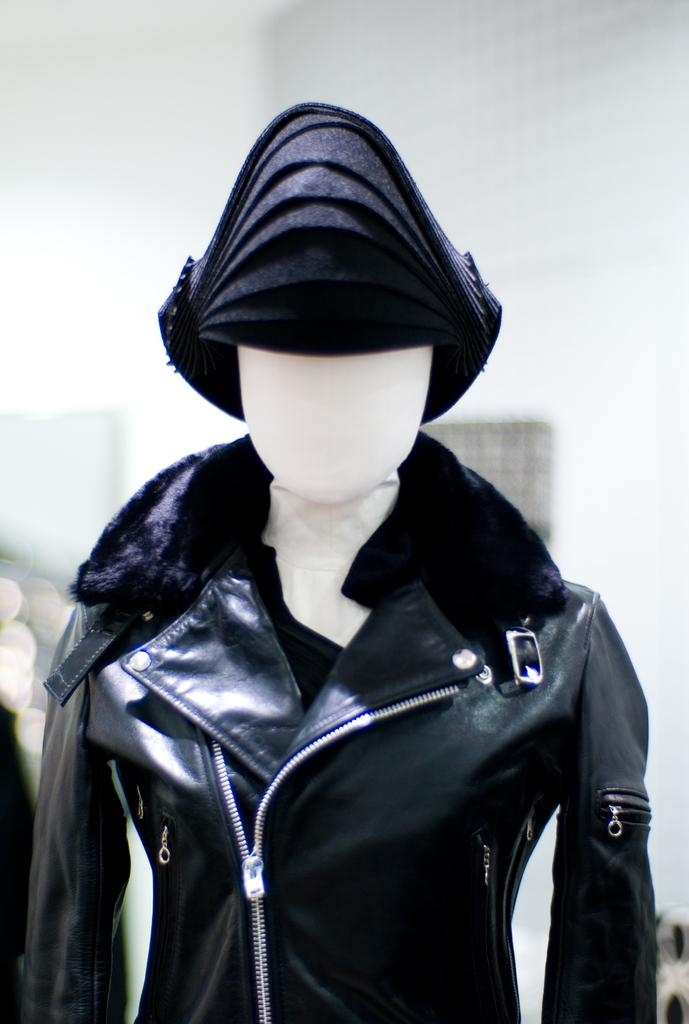What is the main subject in the picture? There is a mannequin in the picture. What is the mannequin wearing in the picture? There is a black color jacket in the picture. Can you tell me how the woman in the picture is controlling the mannequin? There is no woman present in the image, and the mannequin is not being controlled by anyone. 